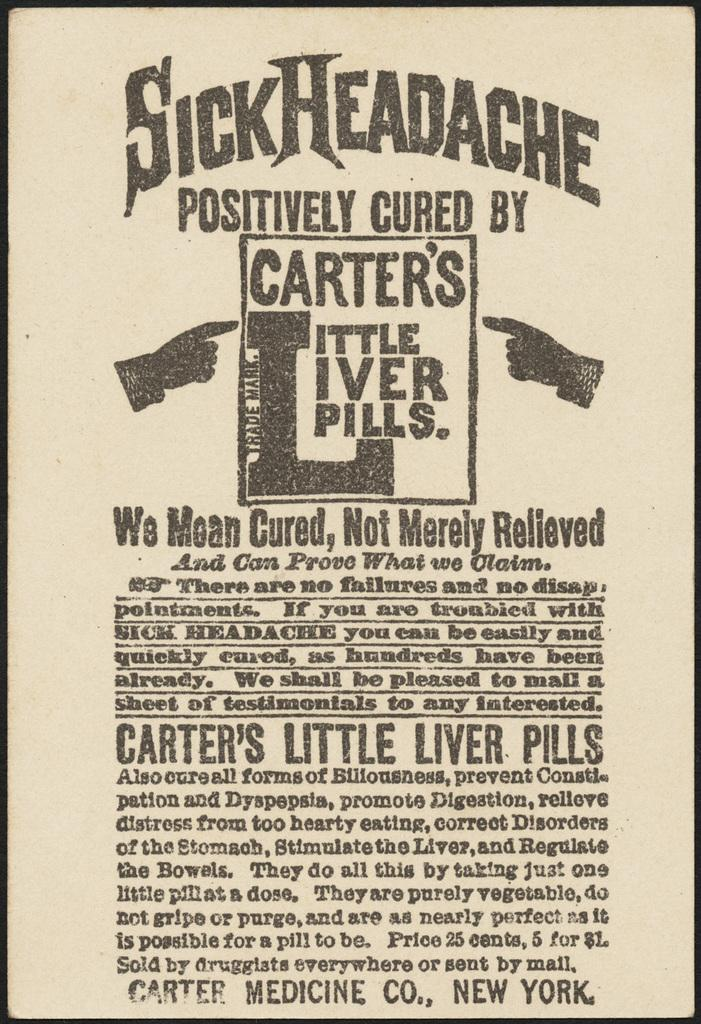What is the main subject of the image? The main subject of the image is a paper with many English alphabets written on it. Can you describe the content of the paper? The paper contains English alphabets. What type of jelly can be seen in the image? There is no jelly present in the image; it only features a paper with English alphabets written on it. Is there a quartz crystal visible in the image? No, there is no quartz crystal present in the image. 